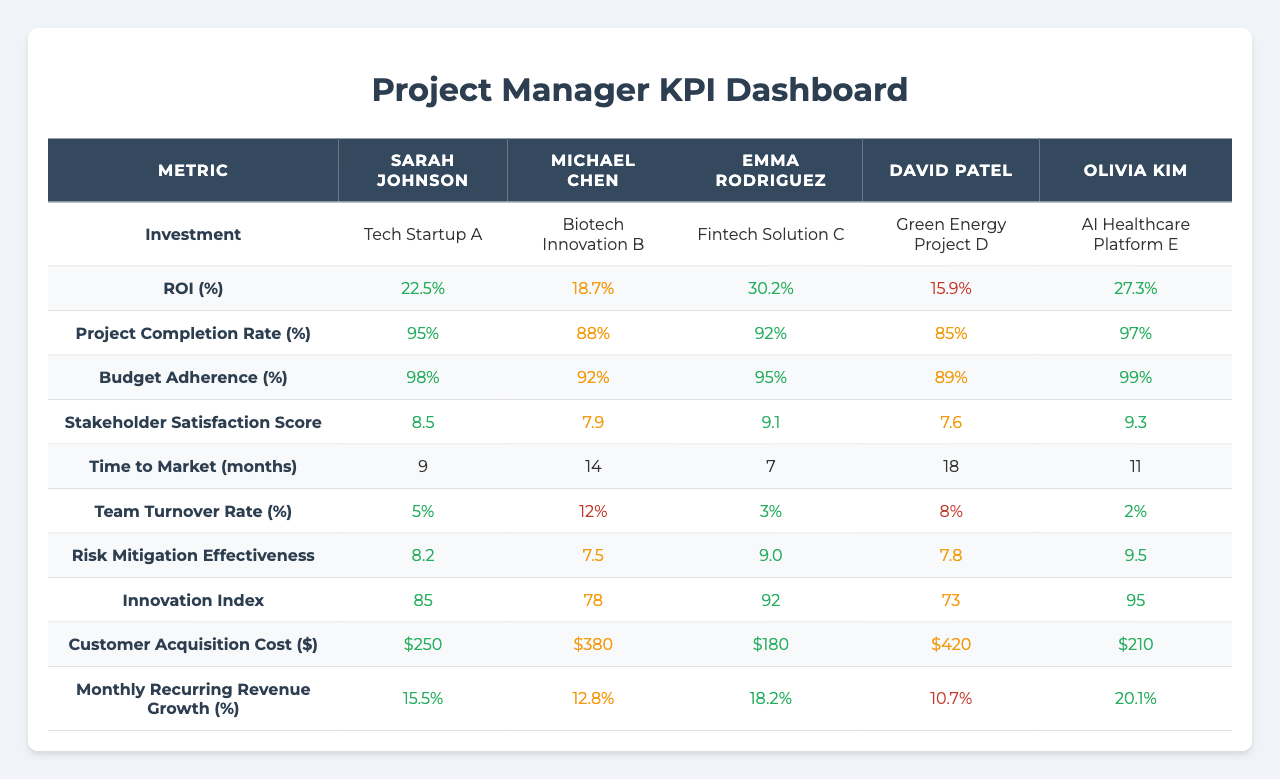What is the ROI for the Fintech Solution C investment? The ROI for Fintech Solution C is listed under the "ROI (%)" row in the table, which shows 30.2%.
Answer: 30.2% Which project manager has the highest project completion rate? By comparing the "Project Completion Rate (%)" row values, Olivia Kim has the highest rate at 97%.
Answer: Olivia Kim What is the average Stakeholder Satisfaction Score across all project managers? The scores are 8.5, 7.9, 9.1, 7.6, and 9.3. The average can be computed as (8.5 + 7.9 + 9.1 + 7.6 + 9.3) / 5 = 8.52.
Answer: 8.52 Does David Patel have a lower than average ROI? The average ROI is (22.5 + 18.7 + 30.2 + 15.9 + 27.3) / 5 = 22.92%. David Patel's ROI is 15.9%, which is lower than the average.
Answer: Yes What is the difference in Budget Adherence between Sarah Johnson and Emma Rodriguez? Sarah Johnson's Budget Adherence is 98%, and Emma Rodriguez's is 95%. The difference is 98 - 95 = 3%.
Answer: 3% Which project has the lowest Customer Acquisition Cost, and what is that cost? Looking at the "Customer Acquisition Cost ($)" row, Fintech Solution C has the lowest cost of $180.
Answer: Fintech Solution C, $180 Calculate the median Time to Market for the recorded projects. The recorded times are 9, 14, 7, 18, and 11 months. Arranging these in order gives 7, 9, 11, 14, 18. The median is the middle value, which is 11.
Answer: 11 Is there a project manager who maintained a Team Turnover Rate of less than 5%? By reviewing the "Team Turnover Rate (%)" values, the lowest is 2% for Olivia Kim, indicating she maintained a rate below 5%.
Answer: Yes What is the highest Risk Mitigation Effectiveness score, and which project manager achieved it? The highest score in "Risk Mitigation Effectiveness (1-10)" is 9.5 from Olivia Kim.
Answer: 9.5, Olivia Kim Considering all investments, which project manager has the most innovative approach as per the Innovation Index? The Innovation Index scores show Emma Rodriguez has the highest score of 92, indicating her project is the most innovative.
Answer: Emma Rodriguez, 92 